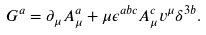Convert formula to latex. <formula><loc_0><loc_0><loc_500><loc_500>G ^ { a } = \partial _ { \mu } A ^ { a } _ { \mu } + \mu \epsilon ^ { a b c } A ^ { c } _ { \mu } v ^ { \mu } \delta ^ { 3 b } .</formula> 